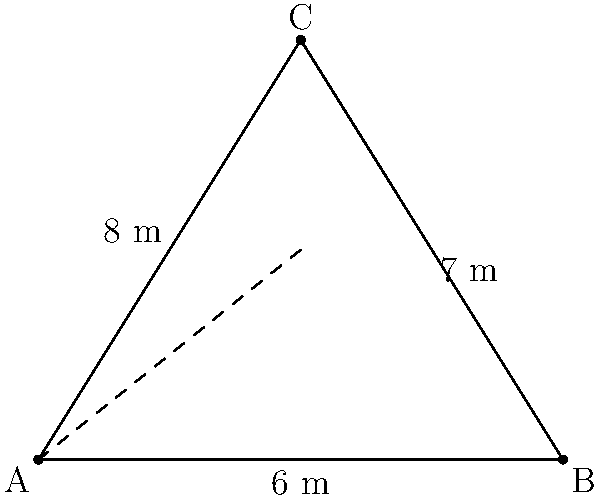In a roof truss, two support beams form a triangle with a horizontal beam. The lengths of the beams are 6 m, 7 m, and 8 m, as shown in the diagram. Using the cosine law, calculate the angle (in degrees) between the two support beams at point C. To find the angle between the two support beams at point C, we'll use the cosine law. Let's follow these steps:

1) The cosine law states that for a triangle with sides a, b, and c, and an angle C opposite side c:

   $$c^2 = a^2 + b^2 - 2ab \cos(C)$$

2) In our case:
   a = 7 m (BC)
   b = 8 m (AC)
   c = 6 m (AB)

3) Substituting these values into the cosine law equation:

   $$6^2 = 7^2 + 8^2 - 2(7)(8) \cos(C)$$

4) Simplify:

   $$36 = 49 + 64 - 112 \cos(C)$$

5) Combine like terms:

   $$36 = 113 - 112 \cos(C)$$

6) Subtract 113 from both sides:

   $$-77 = -112 \cos(C)$$

7) Divide both sides by -112:

   $$\frac{77}{112} = \cos(C)$$

8) Take the inverse cosine (arccos) of both sides:

   $$C = \arccos(\frac{77}{112})$$

9) Calculate the result (in degrees):

   $$C \approx 46.57°$$

Therefore, the angle between the two support beams at point C is approximately 46.57°.
Answer: 46.57° 